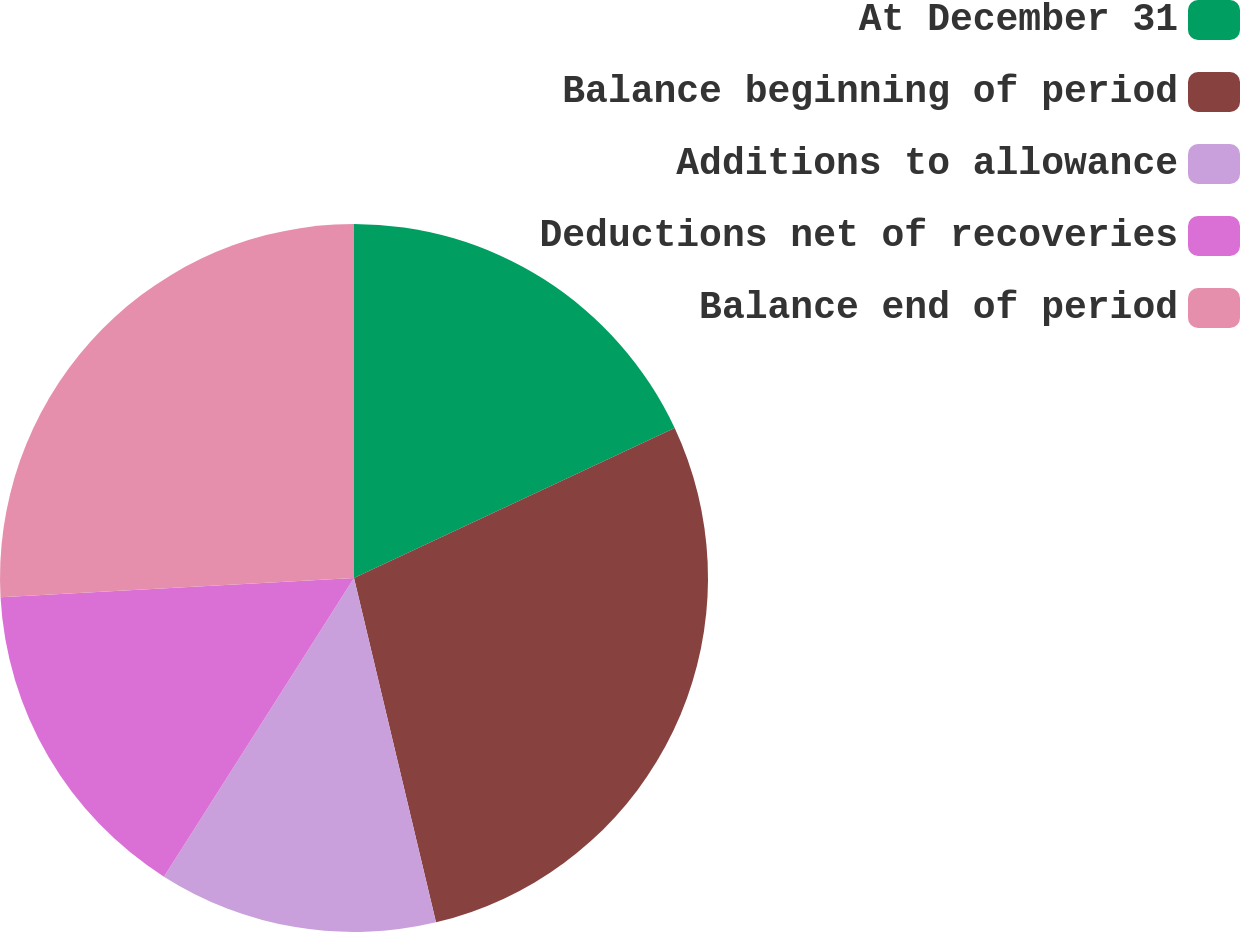<chart> <loc_0><loc_0><loc_500><loc_500><pie_chart><fcel>At December 31<fcel>Balance beginning of period<fcel>Additions to allowance<fcel>Deductions net of recoveries<fcel>Balance end of period<nl><fcel>18.04%<fcel>28.24%<fcel>12.74%<fcel>15.11%<fcel>25.87%<nl></chart> 